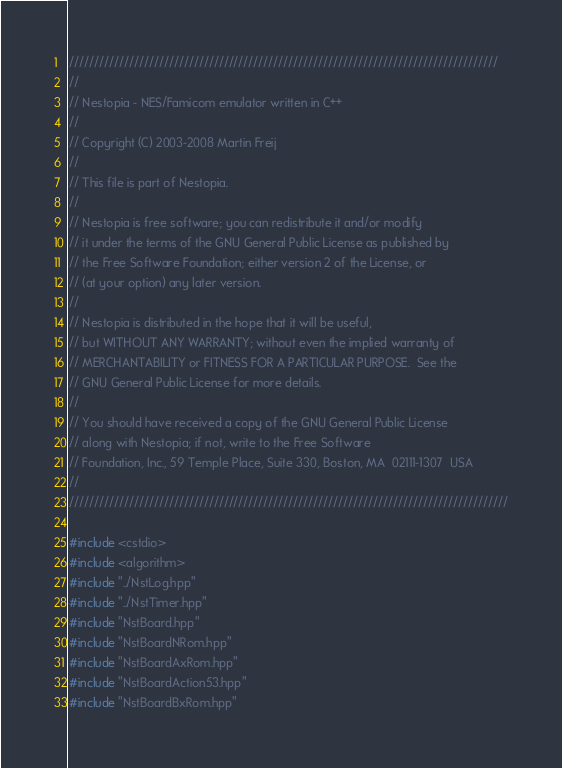<code> <loc_0><loc_0><loc_500><loc_500><_C++_>//////////////////////////////////////////////////////////////////////////////////////
//
// Nestopia - NES/Famicom emulator written in C++
//
// Copyright (C) 2003-2008 Martin Freij
//
// This file is part of Nestopia.
//
// Nestopia is free software; you can redistribute it and/or modify
// it under the terms of the GNU General Public License as published by
// the Free Software Foundation; either version 2 of the License, or
// (at your option) any later version.
//
// Nestopia is distributed in the hope that it will be useful,
// but WITHOUT ANY WARRANTY; without even the implied warranty of
// MERCHANTABILITY or FITNESS FOR A PARTICULAR PURPOSE.  See the
// GNU General Public License for more details.
//
// You should have received a copy of the GNU General Public License
// along with Nestopia; if not, write to the Free Software
// Foundation, Inc., 59 Temple Place, Suite 330, Boston, MA  02111-1307  USA
//
////////////////////////////////////////////////////////////////////////////////////////

#include <cstdio>
#include <algorithm>
#include "../NstLog.hpp"
#include "../NstTimer.hpp"
#include "NstBoard.hpp"
#include "NstBoardNRom.hpp"
#include "NstBoardAxRom.hpp"
#include "NstBoardAction53.hpp"
#include "NstBoardBxRom.hpp"</code> 